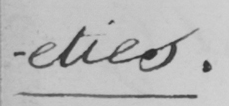Transcribe the text shown in this historical manuscript line. -eties . 